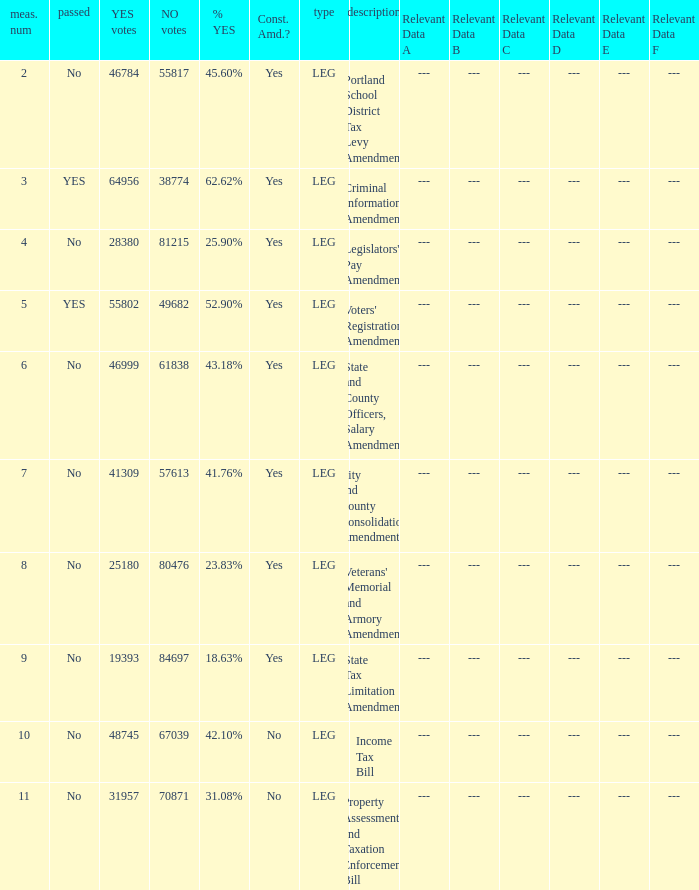Who had 41.76% yes votes City and County Consolidation Amendment. 